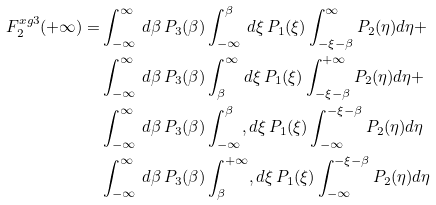<formula> <loc_0><loc_0><loc_500><loc_500>F _ { 2 } ^ { x g 3 } ( + \infty ) = & \int _ { - \infty } ^ { \infty } \, d \beta \, P _ { 3 } ( \beta ) \int _ { - \infty } ^ { \beta } \, d \xi \, P _ { 1 } ( \xi ) \int _ { - \xi - \beta } ^ { \infty } P _ { 2 } ( \eta ) d \eta + \\ & \int _ { - \infty } ^ { \infty } \, d \beta \, P _ { 3 } ( \beta ) \int _ { \beta } ^ { \infty } \, d \xi \, P _ { 1 } ( \xi ) \int _ { - \xi - \beta } ^ { + \infty } P _ { 2 } ( \eta ) d \eta + \\ & \int _ { - \infty } ^ { \infty } \, d \beta \, P _ { 3 } ( \beta ) \int _ { - \infty } ^ { \beta } , d \xi \, P _ { 1 } ( \xi ) \int _ { - \infty } ^ { - \xi - \beta } P _ { 2 } ( \eta ) d \eta \\ & \int _ { - \infty } ^ { \infty } \, d \beta \, P _ { 3 } ( \beta ) \int _ { \beta } ^ { + \infty } , d \xi \, P _ { 1 } ( \xi ) \int _ { - \infty } ^ { - \xi - \beta } P _ { 2 } ( \eta ) d \eta</formula> 